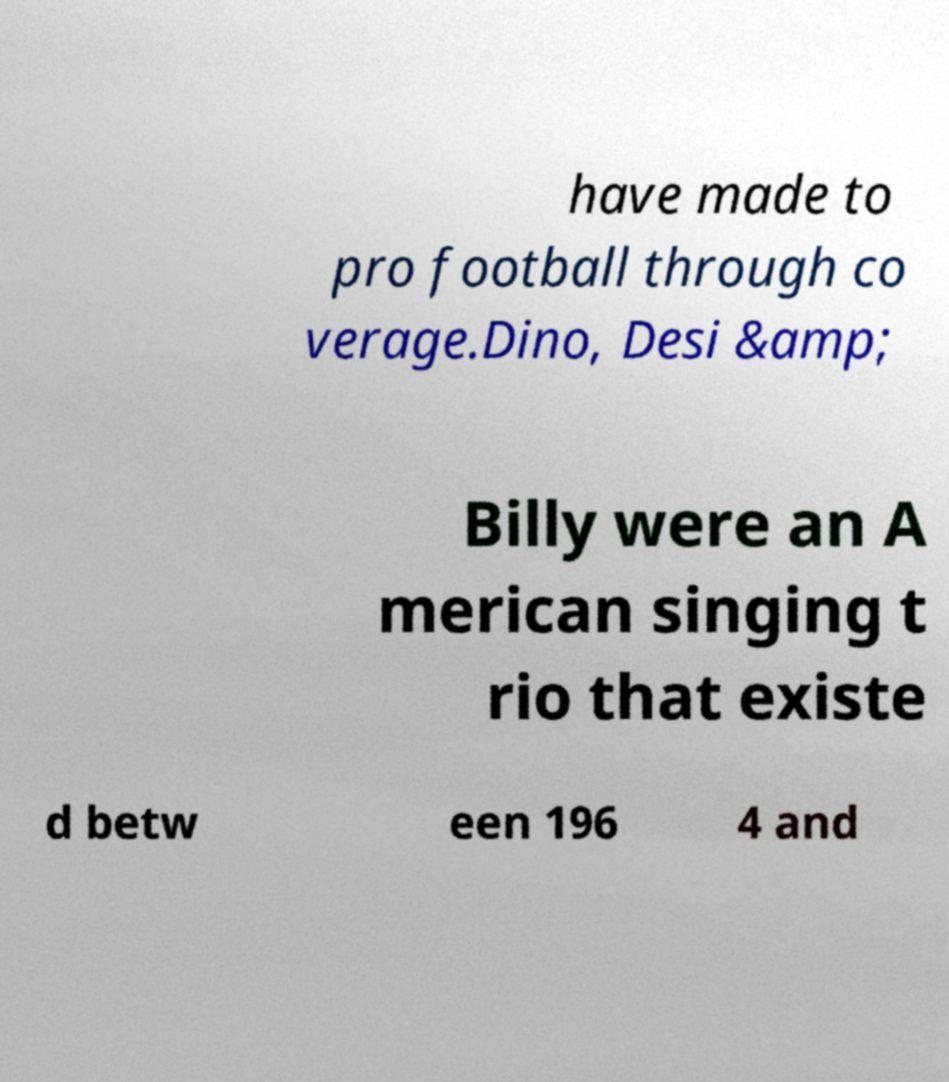Can you read and provide the text displayed in the image?This photo seems to have some interesting text. Can you extract and type it out for me? have made to pro football through co verage.Dino, Desi &amp; Billy were an A merican singing t rio that existe d betw een 196 4 and 